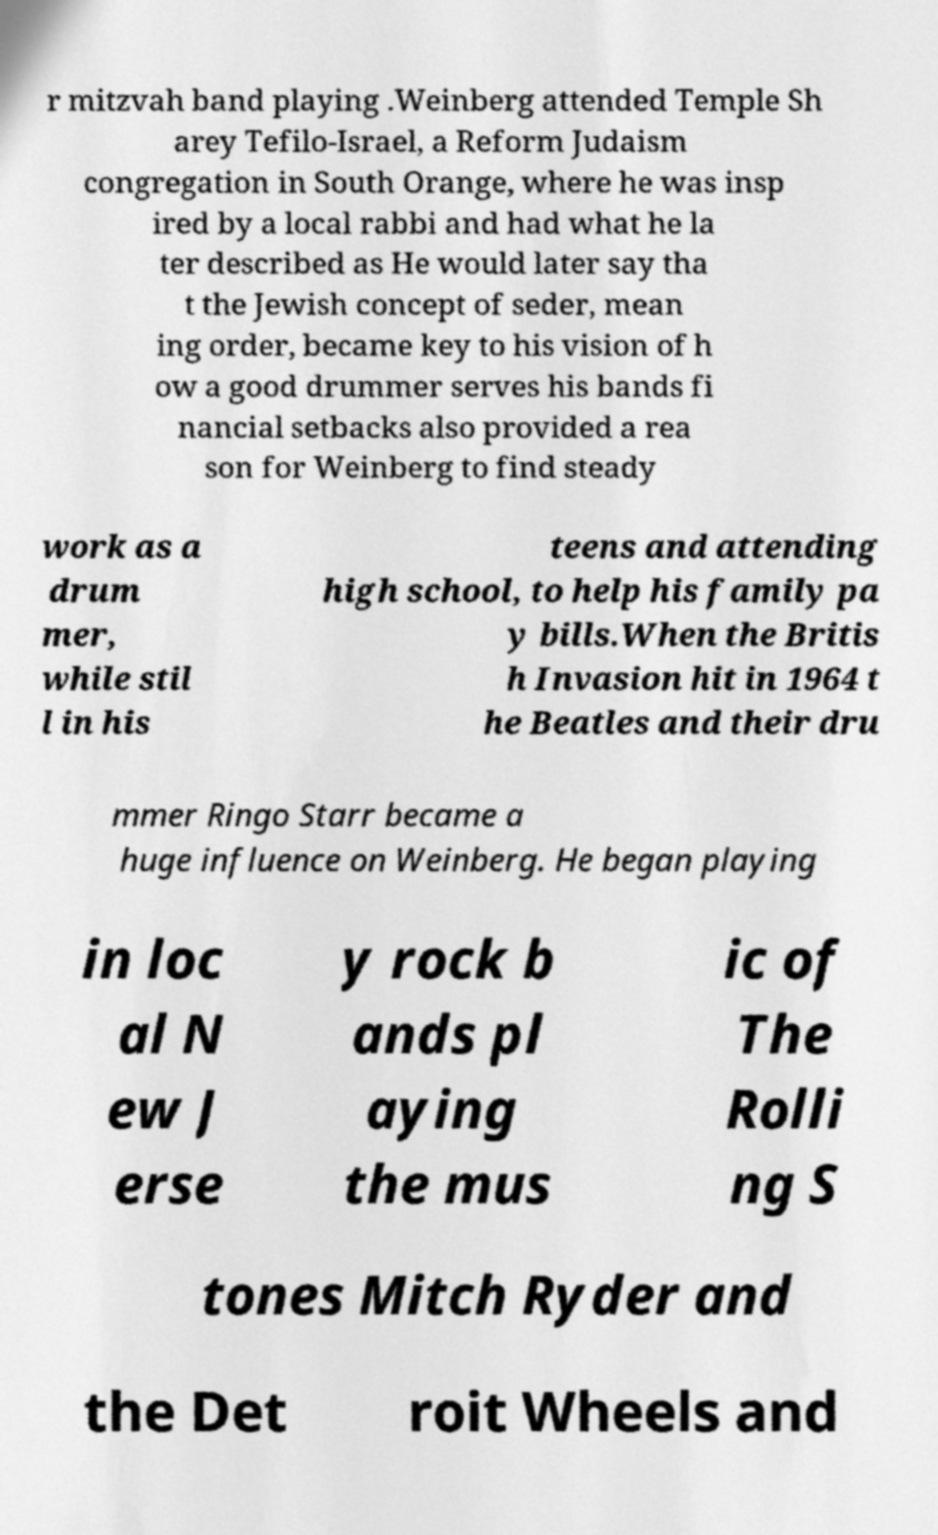For documentation purposes, I need the text within this image transcribed. Could you provide that? r mitzvah band playing .Weinberg attended Temple Sh arey Tefilo-Israel, a Reform Judaism congregation in South Orange, where he was insp ired by a local rabbi and had what he la ter described as He would later say tha t the Jewish concept of seder, mean ing order, became key to his vision of h ow a good drummer serves his bands fi nancial setbacks also provided a rea son for Weinberg to find steady work as a drum mer, while stil l in his teens and attending high school, to help his family pa y bills.When the Britis h Invasion hit in 1964 t he Beatles and their dru mmer Ringo Starr became a huge influence on Weinberg. He began playing in loc al N ew J erse y rock b ands pl aying the mus ic of The Rolli ng S tones Mitch Ryder and the Det roit Wheels and 